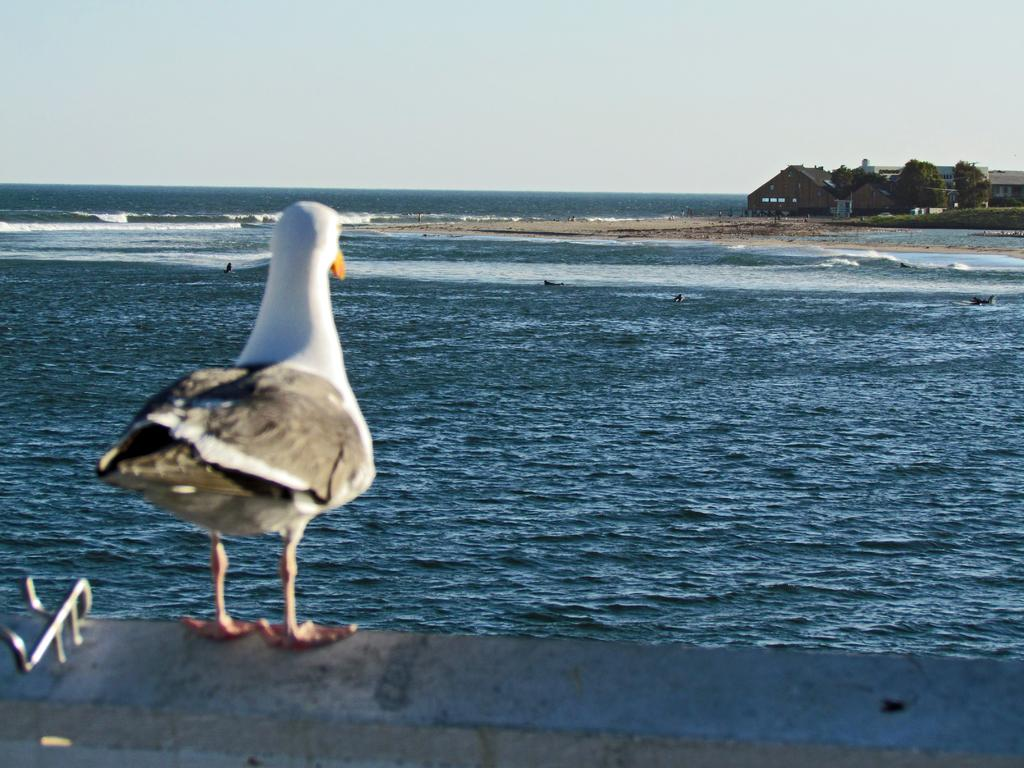What type of animal can be seen on the left side of the image? There is a bird on the left side of the image. What structures are located on the right side of the image? There are houses on the right side of the image. What natural feature is visible in the background of the image? There is an ocean in the background of the image. What else can be seen in the background of the image? The sky is visible in the background of the image. What type of bell can be heard ringing in the image? There is no bell present in the image, and therefore no sound can be heard. Can you tell me the relation between the bird and the houses in the image? The image does not provide any information about the relationship between the bird and the houses; it only shows their respective locations. 